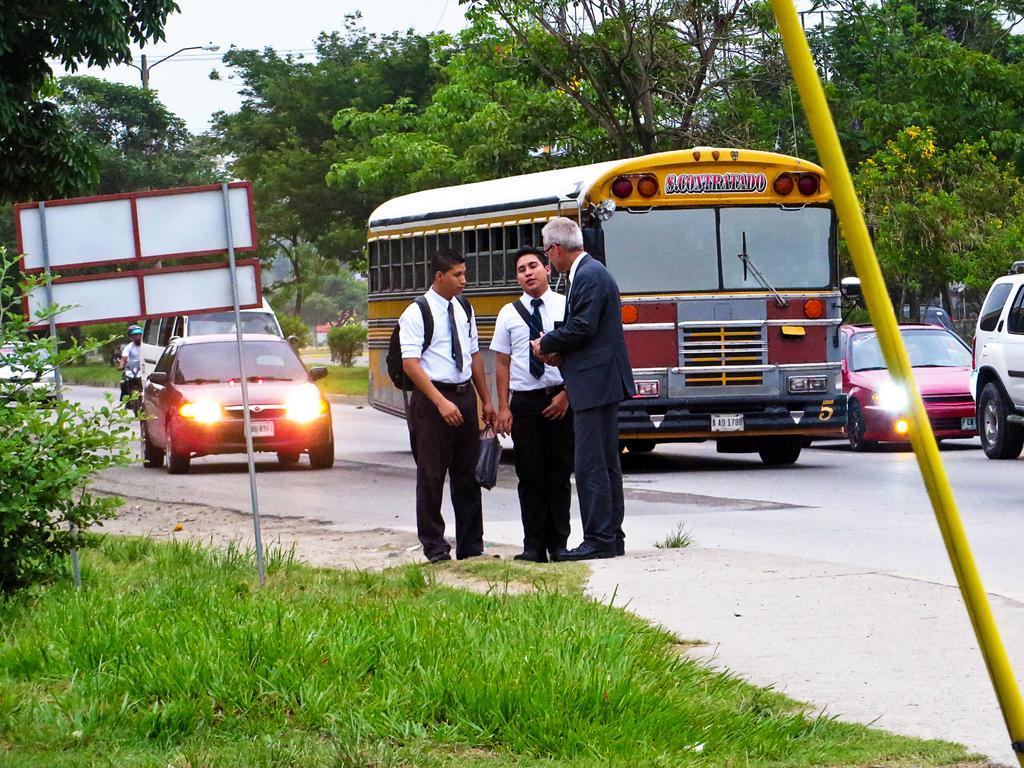Please provide a concise description of this image. In this image in the center there are three persons who are standing and talking, and at the bottom there is a road. On the road there are some cars buses and bikes, and in the foreground there is one pole. On the left side there is one board, plants and grass. In the background there are some trees, pole, light and some wires. 